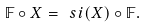Convert formula to latex. <formula><loc_0><loc_0><loc_500><loc_500>\mathbb { F } \circ X = \ s i ( X ) \circ \mathbb { F } .</formula> 